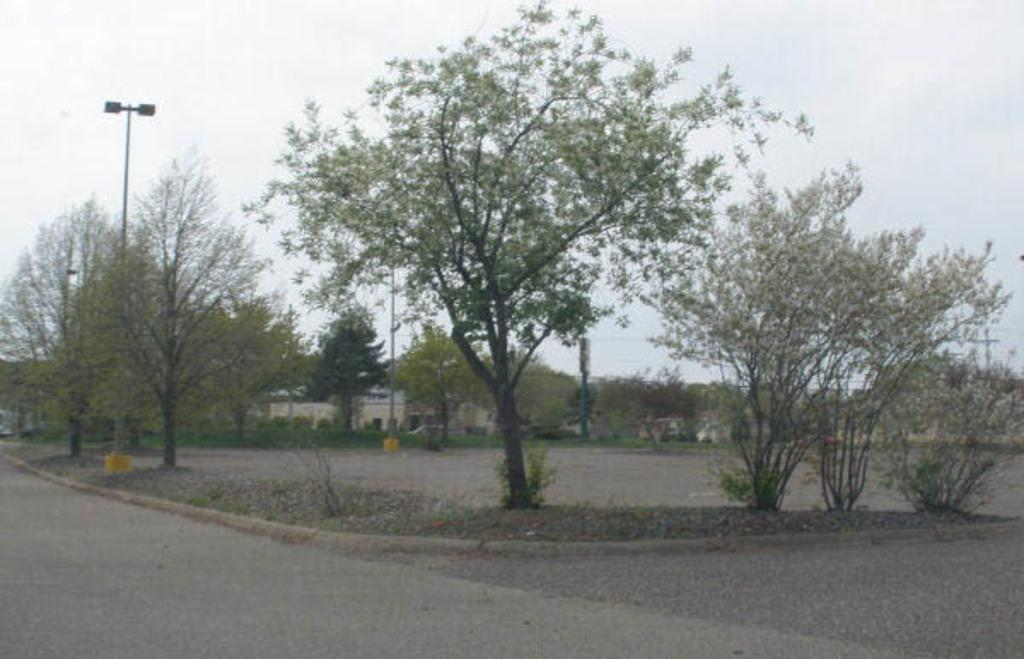What type of vegetation is present in the image? There are trees in the image. What is the color of the trees? The trees are green. What can be seen in the background of the image? There are light poles and buildings in the background of the image. What is the color of the sky in the image? The sky is white in color. What type of furniture can be seen in the image? There is no furniture present in the image. How does the image provide comfort to the viewer? The image does not provide comfort to the viewer, as it is a static representation of trees, light poles, buildings, and the sky. 